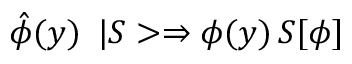Convert formula to latex. <formula><loc_0><loc_0><loc_500><loc_500>\hat { \phi } ( y ) \, \ | S > \Rightarrow \phi ( y ) \, S [ \phi ]</formula> 